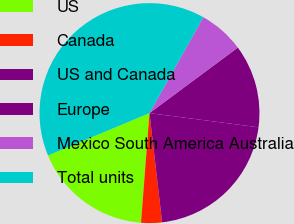Convert chart. <chart><loc_0><loc_0><loc_500><loc_500><pie_chart><fcel>US<fcel>Canada<fcel>US and Canada<fcel>Europe<fcel>Mexico South America Australia<fcel>Total units<nl><fcel>17.47%<fcel>3.06%<fcel>21.11%<fcel>12.22%<fcel>6.7%<fcel>39.44%<nl></chart> 